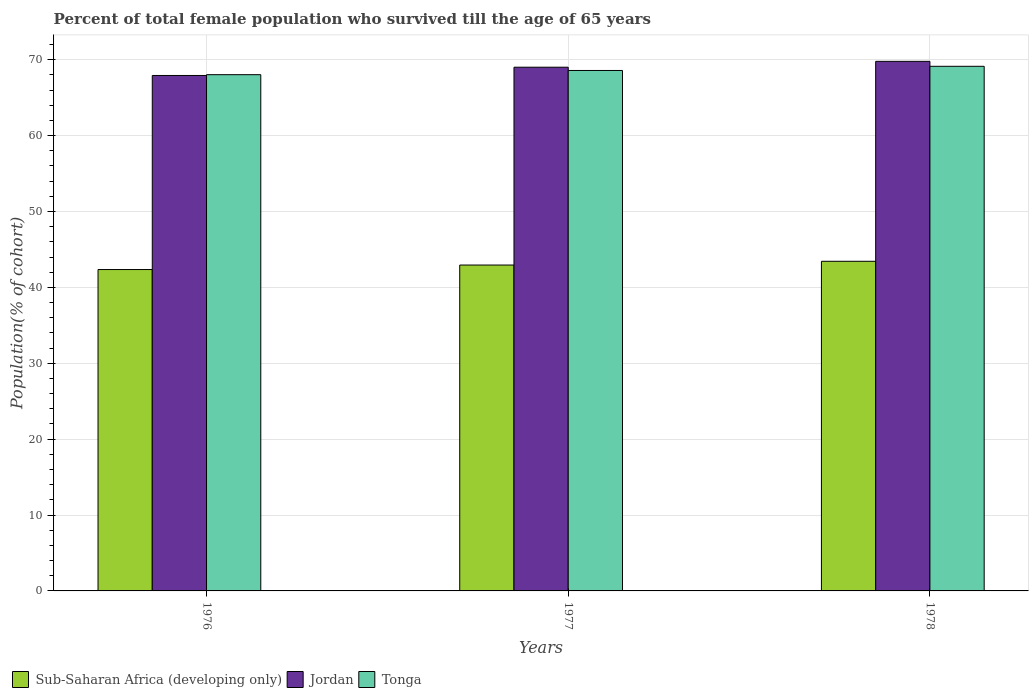How many groups of bars are there?
Ensure brevity in your answer.  3. How many bars are there on the 3rd tick from the right?
Offer a terse response. 3. What is the percentage of total female population who survived till the age of 65 years in Tonga in 1978?
Your answer should be compact. 69.14. Across all years, what is the maximum percentage of total female population who survived till the age of 65 years in Jordan?
Ensure brevity in your answer.  69.79. Across all years, what is the minimum percentage of total female population who survived till the age of 65 years in Jordan?
Offer a very short reply. 67.93. In which year was the percentage of total female population who survived till the age of 65 years in Jordan maximum?
Provide a succinct answer. 1978. In which year was the percentage of total female population who survived till the age of 65 years in Tonga minimum?
Offer a terse response. 1976. What is the total percentage of total female population who survived till the age of 65 years in Jordan in the graph?
Your answer should be compact. 206.73. What is the difference between the percentage of total female population who survived till the age of 65 years in Tonga in 1977 and that in 1978?
Make the answer very short. -0.55. What is the difference between the percentage of total female population who survived till the age of 65 years in Tonga in 1977 and the percentage of total female population who survived till the age of 65 years in Sub-Saharan Africa (developing only) in 1976?
Provide a succinct answer. 26.23. What is the average percentage of total female population who survived till the age of 65 years in Jordan per year?
Make the answer very short. 68.91. In the year 1978, what is the difference between the percentage of total female population who survived till the age of 65 years in Tonga and percentage of total female population who survived till the age of 65 years in Jordan?
Offer a terse response. -0.65. In how many years, is the percentage of total female population who survived till the age of 65 years in Sub-Saharan Africa (developing only) greater than 44 %?
Offer a very short reply. 0. What is the ratio of the percentage of total female population who survived till the age of 65 years in Tonga in 1976 to that in 1978?
Your response must be concise. 0.98. Is the percentage of total female population who survived till the age of 65 years in Tonga in 1976 less than that in 1977?
Keep it short and to the point. Yes. What is the difference between the highest and the second highest percentage of total female population who survived till the age of 65 years in Tonga?
Keep it short and to the point. 0.55. What is the difference between the highest and the lowest percentage of total female population who survived till the age of 65 years in Jordan?
Your answer should be compact. 1.86. In how many years, is the percentage of total female population who survived till the age of 65 years in Tonga greater than the average percentage of total female population who survived till the age of 65 years in Tonga taken over all years?
Your answer should be very brief. 2. What does the 3rd bar from the left in 1976 represents?
Offer a terse response. Tonga. What does the 3rd bar from the right in 1976 represents?
Your answer should be very brief. Sub-Saharan Africa (developing only). Is it the case that in every year, the sum of the percentage of total female population who survived till the age of 65 years in Sub-Saharan Africa (developing only) and percentage of total female population who survived till the age of 65 years in Tonga is greater than the percentage of total female population who survived till the age of 65 years in Jordan?
Provide a succinct answer. Yes. How many legend labels are there?
Offer a very short reply. 3. What is the title of the graph?
Make the answer very short. Percent of total female population who survived till the age of 65 years. Does "Norway" appear as one of the legend labels in the graph?
Keep it short and to the point. No. What is the label or title of the Y-axis?
Your answer should be very brief. Population(% of cohort). What is the Population(% of cohort) of Sub-Saharan Africa (developing only) in 1976?
Keep it short and to the point. 42.35. What is the Population(% of cohort) in Jordan in 1976?
Your answer should be compact. 67.93. What is the Population(% of cohort) in Tonga in 1976?
Give a very brief answer. 68.03. What is the Population(% of cohort) of Sub-Saharan Africa (developing only) in 1977?
Keep it short and to the point. 42.95. What is the Population(% of cohort) of Jordan in 1977?
Offer a terse response. 69.02. What is the Population(% of cohort) of Tonga in 1977?
Offer a very short reply. 68.59. What is the Population(% of cohort) in Sub-Saharan Africa (developing only) in 1978?
Keep it short and to the point. 43.44. What is the Population(% of cohort) in Jordan in 1978?
Your response must be concise. 69.79. What is the Population(% of cohort) of Tonga in 1978?
Give a very brief answer. 69.14. Across all years, what is the maximum Population(% of cohort) of Sub-Saharan Africa (developing only)?
Provide a succinct answer. 43.44. Across all years, what is the maximum Population(% of cohort) in Jordan?
Keep it short and to the point. 69.79. Across all years, what is the maximum Population(% of cohort) in Tonga?
Offer a terse response. 69.14. Across all years, what is the minimum Population(% of cohort) in Sub-Saharan Africa (developing only)?
Provide a short and direct response. 42.35. Across all years, what is the minimum Population(% of cohort) of Jordan?
Keep it short and to the point. 67.93. Across all years, what is the minimum Population(% of cohort) of Tonga?
Make the answer very short. 68.03. What is the total Population(% of cohort) in Sub-Saharan Africa (developing only) in the graph?
Keep it short and to the point. 128.74. What is the total Population(% of cohort) in Jordan in the graph?
Offer a terse response. 206.73. What is the total Population(% of cohort) in Tonga in the graph?
Your answer should be very brief. 205.75. What is the difference between the Population(% of cohort) in Sub-Saharan Africa (developing only) in 1976 and that in 1977?
Offer a terse response. -0.59. What is the difference between the Population(% of cohort) of Jordan in 1976 and that in 1977?
Provide a succinct answer. -1.09. What is the difference between the Population(% of cohort) in Tonga in 1976 and that in 1977?
Your response must be concise. -0.55. What is the difference between the Population(% of cohort) in Sub-Saharan Africa (developing only) in 1976 and that in 1978?
Provide a succinct answer. -1.09. What is the difference between the Population(% of cohort) in Jordan in 1976 and that in 1978?
Keep it short and to the point. -1.86. What is the difference between the Population(% of cohort) in Tonga in 1976 and that in 1978?
Provide a succinct answer. -1.1. What is the difference between the Population(% of cohort) in Sub-Saharan Africa (developing only) in 1977 and that in 1978?
Offer a terse response. -0.5. What is the difference between the Population(% of cohort) in Jordan in 1977 and that in 1978?
Make the answer very short. -0.77. What is the difference between the Population(% of cohort) of Tonga in 1977 and that in 1978?
Provide a short and direct response. -0.55. What is the difference between the Population(% of cohort) of Sub-Saharan Africa (developing only) in 1976 and the Population(% of cohort) of Jordan in 1977?
Your answer should be compact. -26.66. What is the difference between the Population(% of cohort) in Sub-Saharan Africa (developing only) in 1976 and the Population(% of cohort) in Tonga in 1977?
Ensure brevity in your answer.  -26.23. What is the difference between the Population(% of cohort) of Jordan in 1976 and the Population(% of cohort) of Tonga in 1977?
Provide a succinct answer. -0.66. What is the difference between the Population(% of cohort) in Sub-Saharan Africa (developing only) in 1976 and the Population(% of cohort) in Jordan in 1978?
Your answer should be very brief. -27.43. What is the difference between the Population(% of cohort) in Sub-Saharan Africa (developing only) in 1976 and the Population(% of cohort) in Tonga in 1978?
Provide a short and direct response. -26.78. What is the difference between the Population(% of cohort) in Jordan in 1976 and the Population(% of cohort) in Tonga in 1978?
Offer a terse response. -1.21. What is the difference between the Population(% of cohort) of Sub-Saharan Africa (developing only) in 1977 and the Population(% of cohort) of Jordan in 1978?
Your response must be concise. -26.84. What is the difference between the Population(% of cohort) in Sub-Saharan Africa (developing only) in 1977 and the Population(% of cohort) in Tonga in 1978?
Give a very brief answer. -26.19. What is the difference between the Population(% of cohort) of Jordan in 1977 and the Population(% of cohort) of Tonga in 1978?
Your answer should be compact. -0.12. What is the average Population(% of cohort) in Sub-Saharan Africa (developing only) per year?
Your answer should be very brief. 42.91. What is the average Population(% of cohort) of Jordan per year?
Keep it short and to the point. 68.91. What is the average Population(% of cohort) of Tonga per year?
Offer a terse response. 68.58. In the year 1976, what is the difference between the Population(% of cohort) in Sub-Saharan Africa (developing only) and Population(% of cohort) in Jordan?
Provide a short and direct response. -25.57. In the year 1976, what is the difference between the Population(% of cohort) of Sub-Saharan Africa (developing only) and Population(% of cohort) of Tonga?
Your answer should be compact. -25.68. In the year 1976, what is the difference between the Population(% of cohort) in Jordan and Population(% of cohort) in Tonga?
Your answer should be compact. -0.11. In the year 1977, what is the difference between the Population(% of cohort) of Sub-Saharan Africa (developing only) and Population(% of cohort) of Jordan?
Your response must be concise. -26.07. In the year 1977, what is the difference between the Population(% of cohort) in Sub-Saharan Africa (developing only) and Population(% of cohort) in Tonga?
Keep it short and to the point. -25.64. In the year 1977, what is the difference between the Population(% of cohort) of Jordan and Population(% of cohort) of Tonga?
Make the answer very short. 0.43. In the year 1978, what is the difference between the Population(% of cohort) of Sub-Saharan Africa (developing only) and Population(% of cohort) of Jordan?
Ensure brevity in your answer.  -26.35. In the year 1978, what is the difference between the Population(% of cohort) in Sub-Saharan Africa (developing only) and Population(% of cohort) in Tonga?
Your answer should be compact. -25.7. In the year 1978, what is the difference between the Population(% of cohort) of Jordan and Population(% of cohort) of Tonga?
Offer a very short reply. 0.65. What is the ratio of the Population(% of cohort) in Sub-Saharan Africa (developing only) in 1976 to that in 1977?
Your answer should be very brief. 0.99. What is the ratio of the Population(% of cohort) of Jordan in 1976 to that in 1977?
Your answer should be compact. 0.98. What is the ratio of the Population(% of cohort) in Sub-Saharan Africa (developing only) in 1976 to that in 1978?
Your response must be concise. 0.97. What is the ratio of the Population(% of cohort) of Jordan in 1976 to that in 1978?
Make the answer very short. 0.97. What is the ratio of the Population(% of cohort) in Tonga in 1976 to that in 1978?
Give a very brief answer. 0.98. What is the ratio of the Population(% of cohort) in Jordan in 1977 to that in 1978?
Your answer should be compact. 0.99. What is the difference between the highest and the second highest Population(% of cohort) in Sub-Saharan Africa (developing only)?
Ensure brevity in your answer.  0.5. What is the difference between the highest and the second highest Population(% of cohort) of Jordan?
Provide a short and direct response. 0.77. What is the difference between the highest and the second highest Population(% of cohort) of Tonga?
Provide a succinct answer. 0.55. What is the difference between the highest and the lowest Population(% of cohort) of Sub-Saharan Africa (developing only)?
Offer a very short reply. 1.09. What is the difference between the highest and the lowest Population(% of cohort) in Jordan?
Provide a short and direct response. 1.86. What is the difference between the highest and the lowest Population(% of cohort) of Tonga?
Keep it short and to the point. 1.1. 